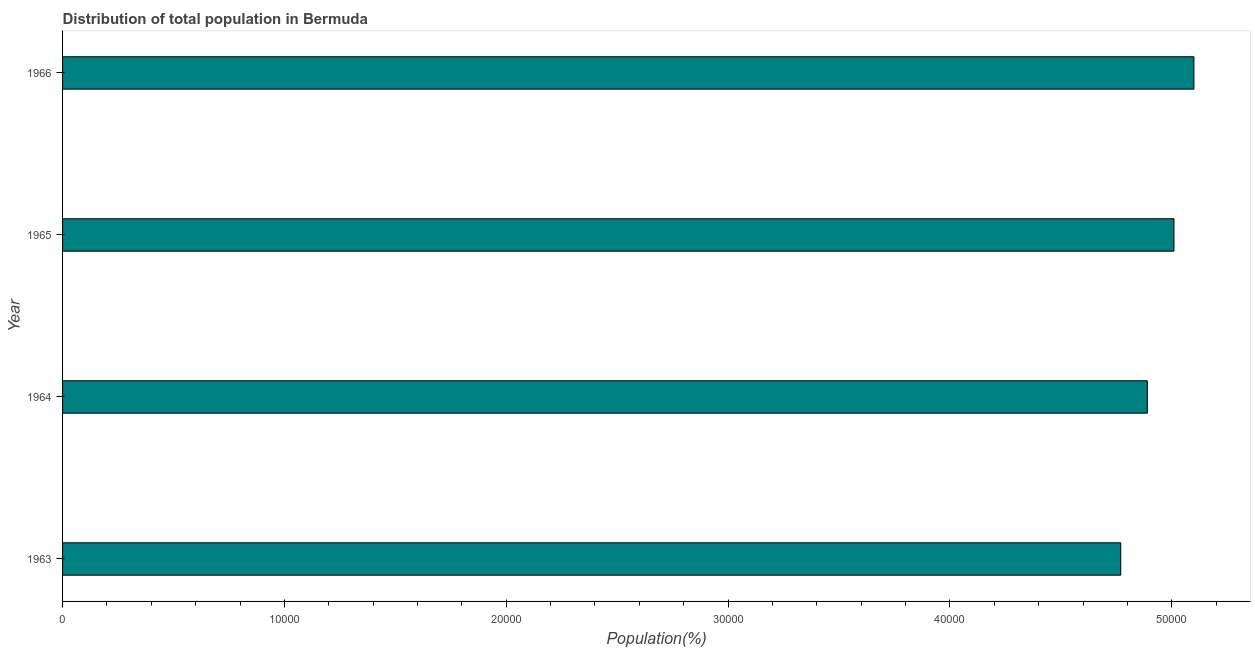Does the graph contain any zero values?
Offer a terse response. No. What is the title of the graph?
Keep it short and to the point. Distribution of total population in Bermuda . What is the label or title of the X-axis?
Give a very brief answer. Population(%). What is the population in 1966?
Your answer should be very brief. 5.10e+04. Across all years, what is the maximum population?
Your answer should be very brief. 5.10e+04. Across all years, what is the minimum population?
Keep it short and to the point. 4.77e+04. In which year was the population maximum?
Ensure brevity in your answer.  1966. What is the sum of the population?
Your response must be concise. 1.98e+05. What is the difference between the population in 1963 and 1964?
Keep it short and to the point. -1200. What is the average population per year?
Your response must be concise. 4.94e+04. What is the median population?
Your response must be concise. 4.95e+04. In how many years, is the population greater than 2000 %?
Offer a very short reply. 4. What is the ratio of the population in 1965 to that in 1966?
Offer a terse response. 0.98. Is the difference between the population in 1963 and 1966 greater than the difference between any two years?
Keep it short and to the point. Yes. What is the difference between the highest and the second highest population?
Your answer should be compact. 900. What is the difference between the highest and the lowest population?
Make the answer very short. 3300. In how many years, is the population greater than the average population taken over all years?
Your answer should be very brief. 2. What is the difference between two consecutive major ticks on the X-axis?
Your answer should be very brief. 10000. Are the values on the major ticks of X-axis written in scientific E-notation?
Provide a succinct answer. No. What is the Population(%) of 1963?
Give a very brief answer. 4.77e+04. What is the Population(%) in 1964?
Your response must be concise. 4.89e+04. What is the Population(%) of 1965?
Give a very brief answer. 5.01e+04. What is the Population(%) of 1966?
Keep it short and to the point. 5.10e+04. What is the difference between the Population(%) in 1963 and 1964?
Give a very brief answer. -1200. What is the difference between the Population(%) in 1963 and 1965?
Make the answer very short. -2400. What is the difference between the Population(%) in 1963 and 1966?
Your answer should be compact. -3300. What is the difference between the Population(%) in 1964 and 1965?
Provide a succinct answer. -1200. What is the difference between the Population(%) in 1964 and 1966?
Make the answer very short. -2100. What is the difference between the Population(%) in 1965 and 1966?
Ensure brevity in your answer.  -900. What is the ratio of the Population(%) in 1963 to that in 1965?
Your answer should be very brief. 0.95. What is the ratio of the Population(%) in 1963 to that in 1966?
Ensure brevity in your answer.  0.94. What is the ratio of the Population(%) in 1964 to that in 1965?
Give a very brief answer. 0.98. What is the ratio of the Population(%) in 1964 to that in 1966?
Ensure brevity in your answer.  0.96. 